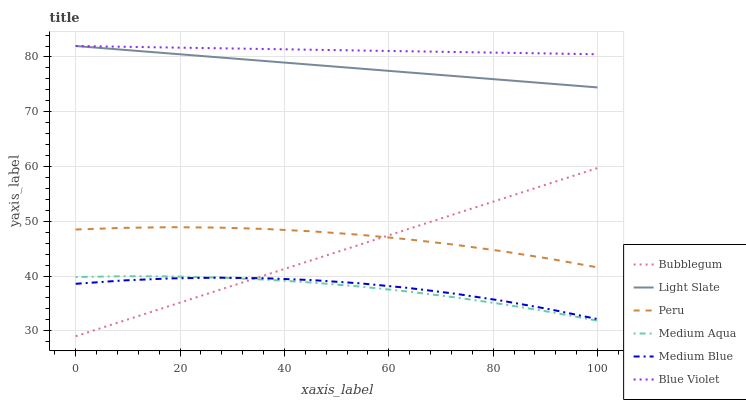Does Medium Aqua have the minimum area under the curve?
Answer yes or no. Yes. Does Blue Violet have the maximum area under the curve?
Answer yes or no. Yes. Does Medium Blue have the minimum area under the curve?
Answer yes or no. No. Does Medium Blue have the maximum area under the curve?
Answer yes or no. No. Is Bubblegum the smoothest?
Answer yes or no. Yes. Is Medium Blue the roughest?
Answer yes or no. Yes. Is Medium Blue the smoothest?
Answer yes or no. No. Is Bubblegum the roughest?
Answer yes or no. No. Does Bubblegum have the lowest value?
Answer yes or no. Yes. Does Medium Blue have the lowest value?
Answer yes or no. No. Does Blue Violet have the highest value?
Answer yes or no. Yes. Does Bubblegum have the highest value?
Answer yes or no. No. Is Medium Blue less than Light Slate?
Answer yes or no. Yes. Is Peru greater than Medium Blue?
Answer yes or no. Yes. Does Peru intersect Bubblegum?
Answer yes or no. Yes. Is Peru less than Bubblegum?
Answer yes or no. No. Is Peru greater than Bubblegum?
Answer yes or no. No. Does Medium Blue intersect Light Slate?
Answer yes or no. No. 